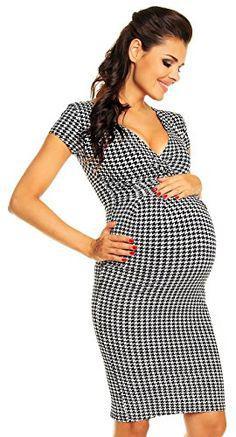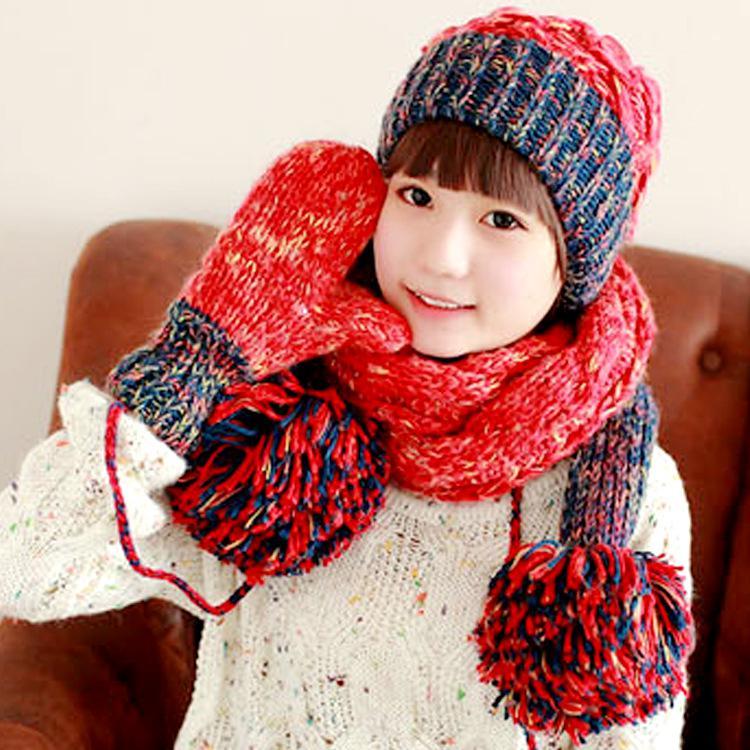The first image is the image on the left, the second image is the image on the right. Analyze the images presented: Is the assertion "Both women are wearing hats with pom poms." valid? Answer yes or no. No. The first image is the image on the left, the second image is the image on the right. For the images shown, is this caption "In one image, a girl is wearing matching hat, mittens and scarf, into which a stripe design has been knitted, with one long end of the scarf draped in front of her." true? Answer yes or no. No. 